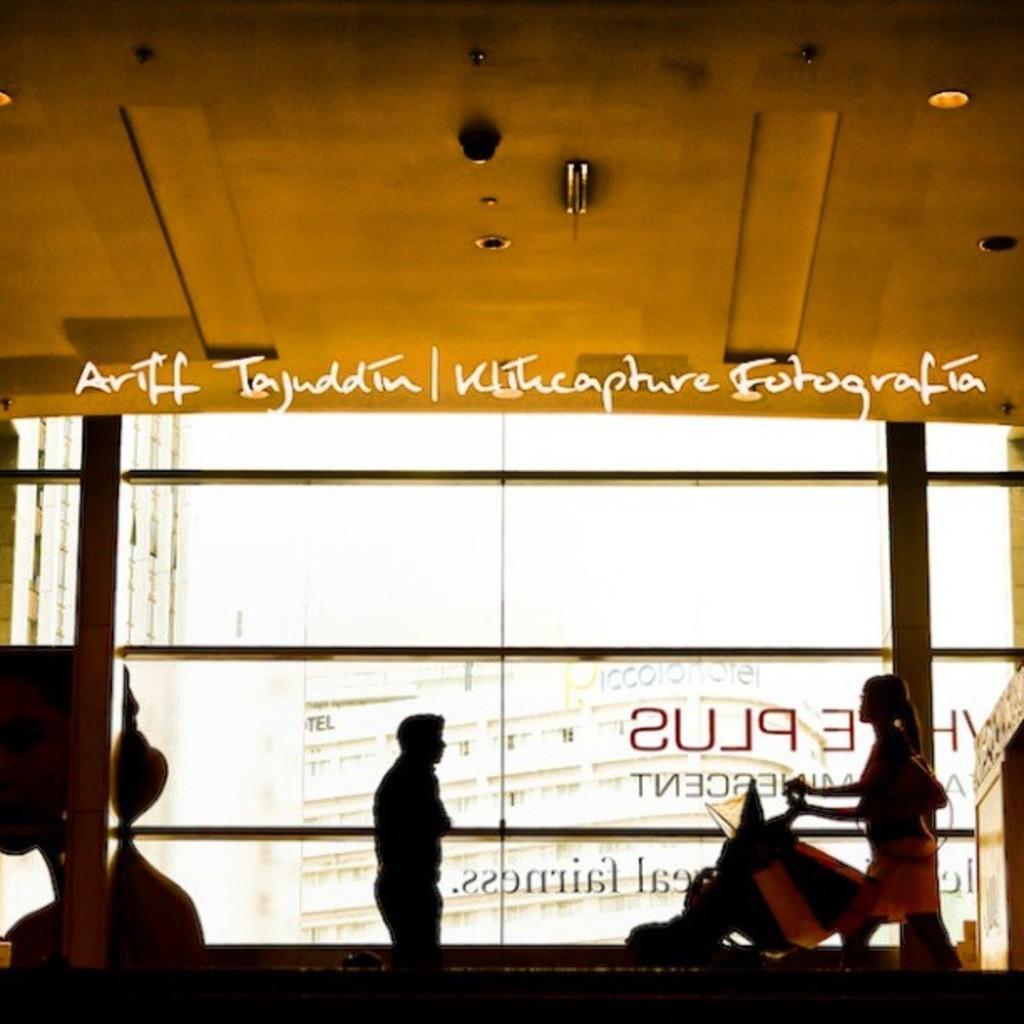Please provide a concise description of this image. In this picture we can see there are two people and a person is holding an object. At the top there are ceiling lights. Behind the people there is the transparent glass and behind the glass there are buildings. On the image there is a watermark. 